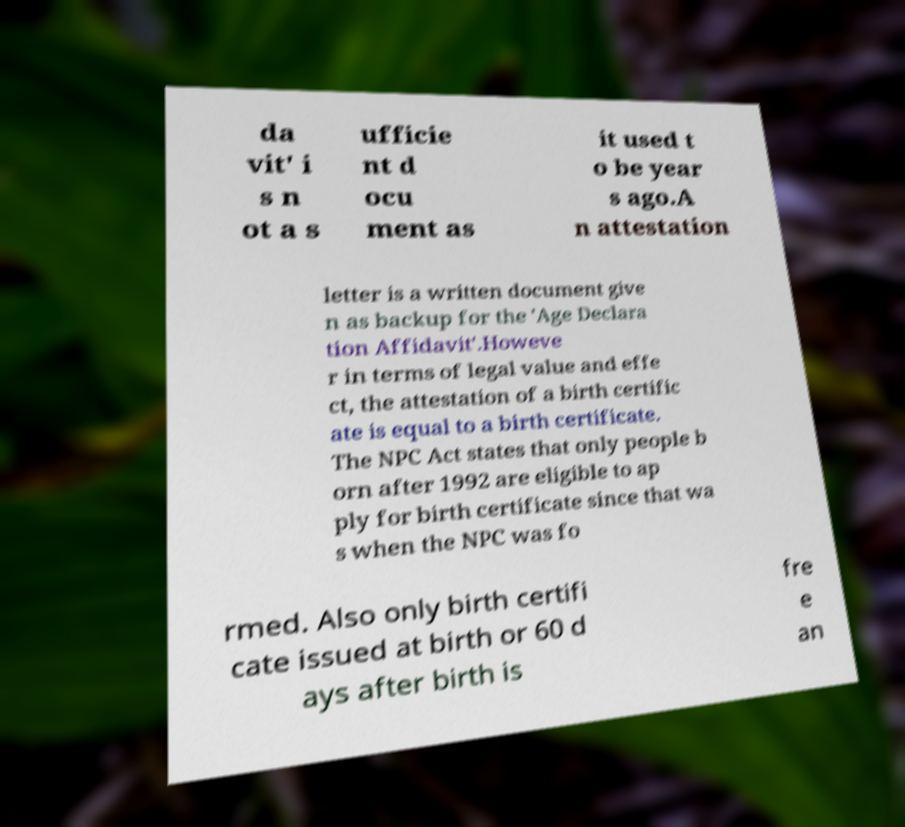For documentation purposes, I need the text within this image transcribed. Could you provide that? da vit' i s n ot a s ufficie nt d ocu ment as it used t o be year s ago.A n attestation letter is a written document give n as backup for the 'Age Declara tion Affidavit'.Howeve r in terms of legal value and effe ct, the attestation of a birth certific ate is equal to a birth certificate. The NPC Act states that only people b orn after 1992 are eligible to ap ply for birth certificate since that wa s when the NPC was fo rmed. Also only birth certifi cate issued at birth or 60 d ays after birth is fre e an 